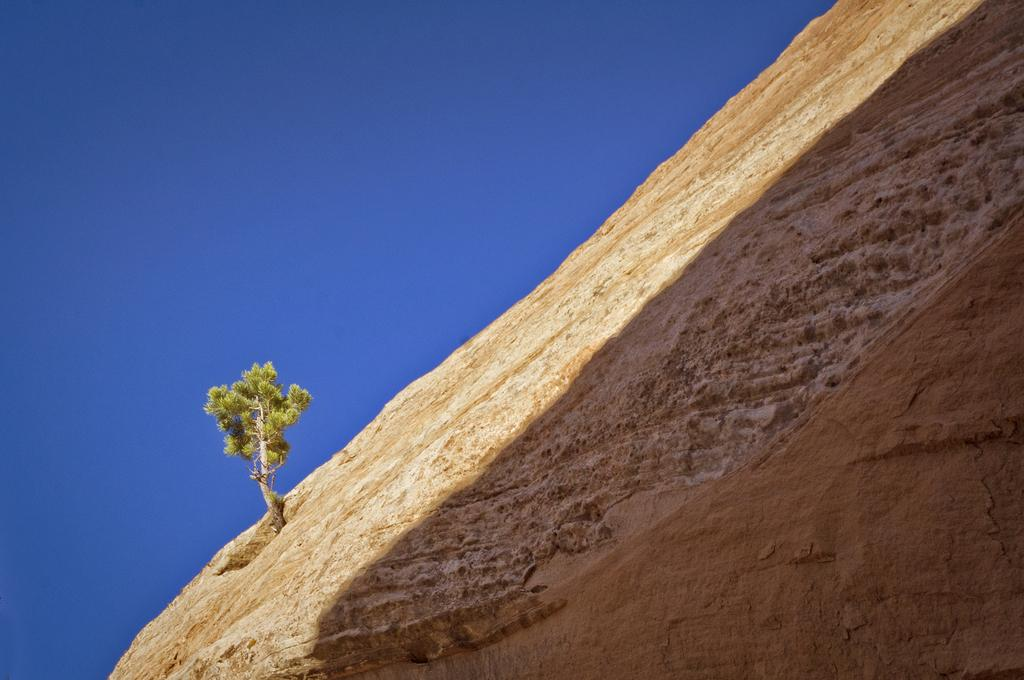What is the main subject of the image? The main subject of the image is a tree. Where is the tree located? The tree is on a rock hill. What is the condition of the sky in the image? The sky is clear in the image. What type of music can be heard coming from the kettle in the image? There is no kettle present in the image, and therefore no music can be heard from it. 